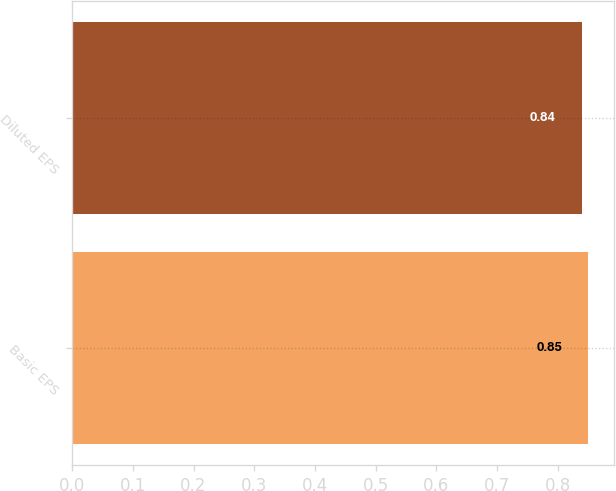Convert chart. <chart><loc_0><loc_0><loc_500><loc_500><bar_chart><fcel>Basic EPS<fcel>Diluted EPS<nl><fcel>0.85<fcel>0.84<nl></chart> 